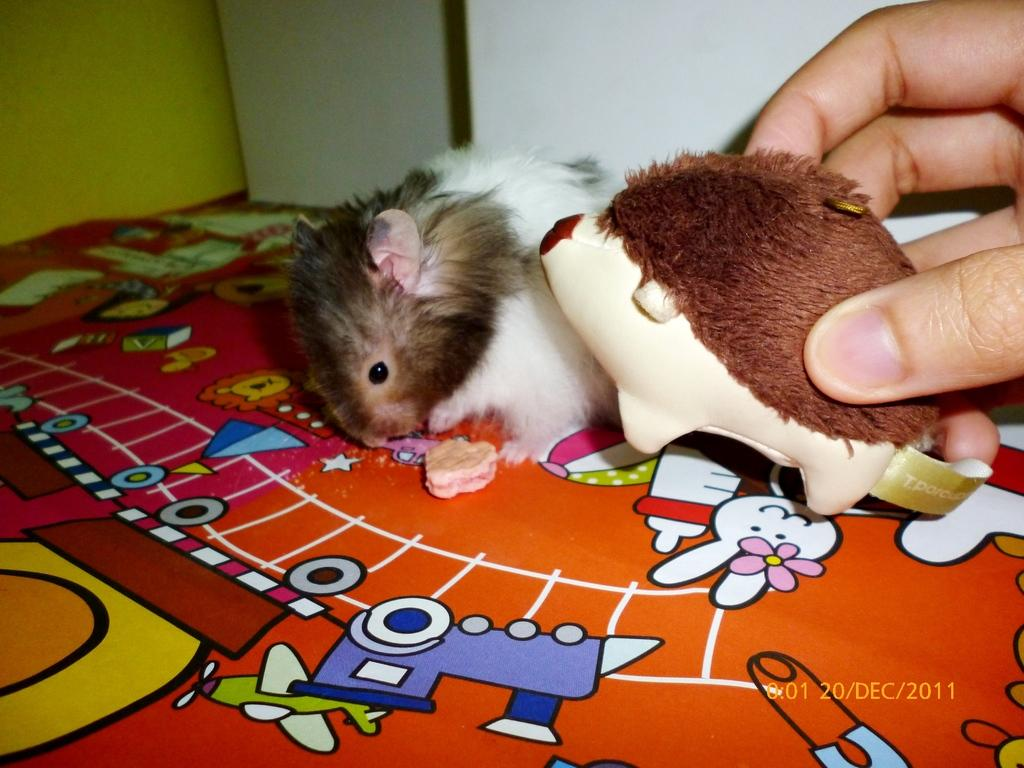Who is present in the image? There is a person in the image. What is the person holding? The person is holding a toy. What other animal can be seen in the image? There is a rat in the image. What is the surface beneath the rat like? The rat is on a colorful surface. What time does the person watch the trouble in the image? There is no mention of trouble or a watch in the image, so this question cannot be answered. 